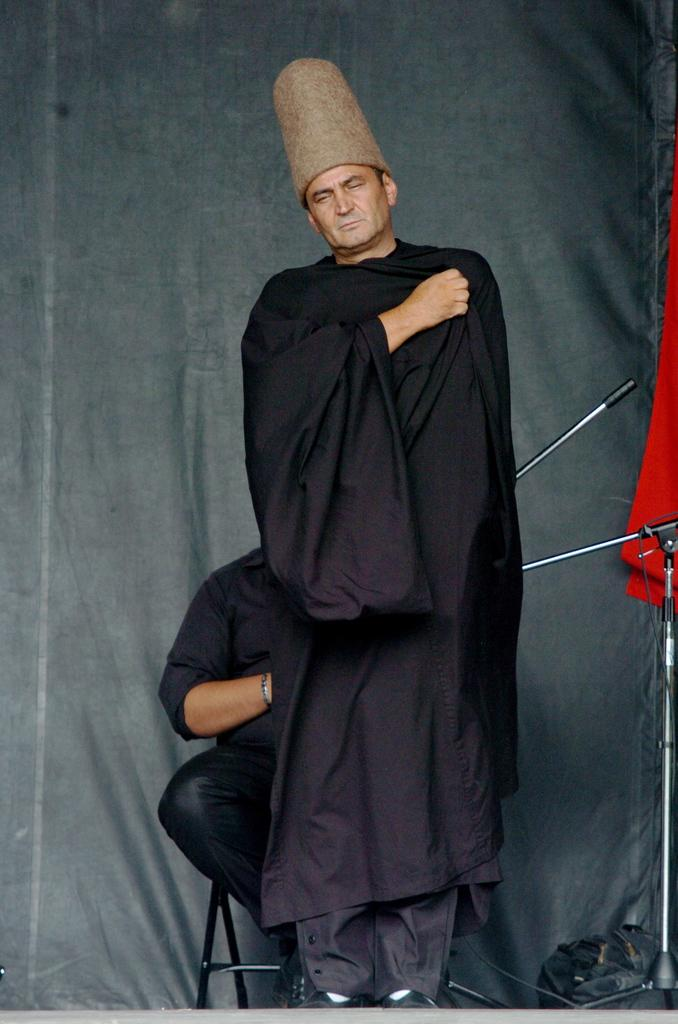What is the man in the image wearing on his head? The man in the image is wearing a cap. What is the man's posture in the image? The man is standing in the image. Can you describe the person in the background? There is a person sitting on a chair in the background. What objects can be seen in the background? A mic stand, a red cloth, a bag, and a curtain are visible in the background. How many cans are visible in the image? There are no cans present in the image. What type of sound does the man make in the image? The image does not depict any sounds or actions, so it cannot be determined what type of sound the man makes. 